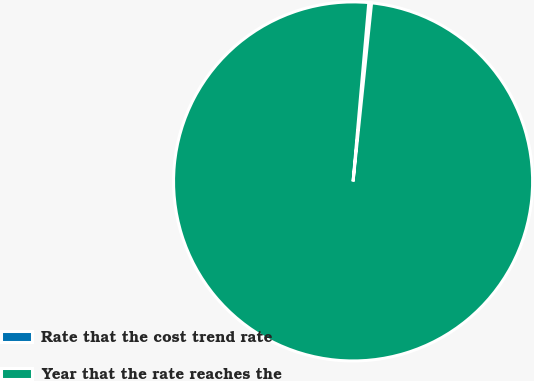Convert chart to OTSL. <chart><loc_0><loc_0><loc_500><loc_500><pie_chart><fcel>Rate that the cost trend rate<fcel>Year that the rate reaches the<nl><fcel>0.25%<fcel>99.75%<nl></chart> 